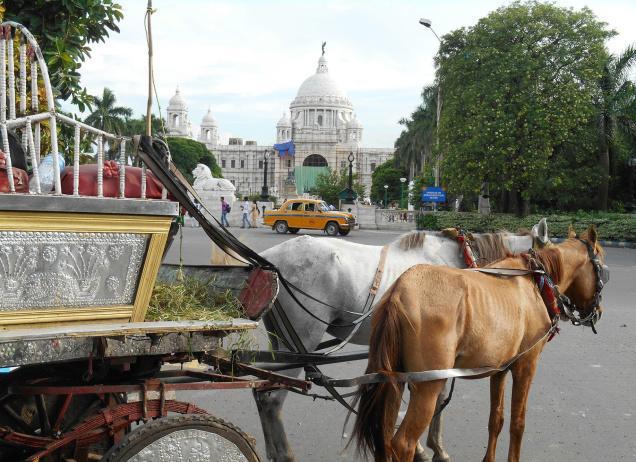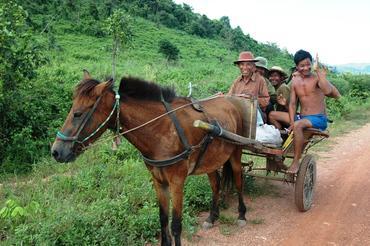The first image is the image on the left, the second image is the image on the right. For the images shown, is this caption "An image shows a leftward-headed wagon with ornate white wheels, pulled by at least one white horse." true? Answer yes or no. No. The first image is the image on the left, the second image is the image on the right. Evaluate the accuracy of this statement regarding the images: "A car is behind a horse carriage.". Is it true? Answer yes or no. Yes. 